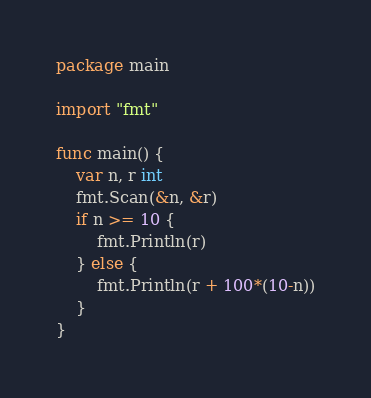<code> <loc_0><loc_0><loc_500><loc_500><_Go_>package main

import "fmt"

func main() {
	var n, r int
	fmt.Scan(&n, &r)
	if n >= 10 {
		fmt.Println(r)
	} else {
		fmt.Println(r + 100*(10-n))
	}
}</code> 